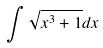<formula> <loc_0><loc_0><loc_500><loc_500>\int \sqrt { x ^ { 3 } + 1 } d x</formula> 